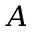<formula> <loc_0><loc_0><loc_500><loc_500>A</formula> 